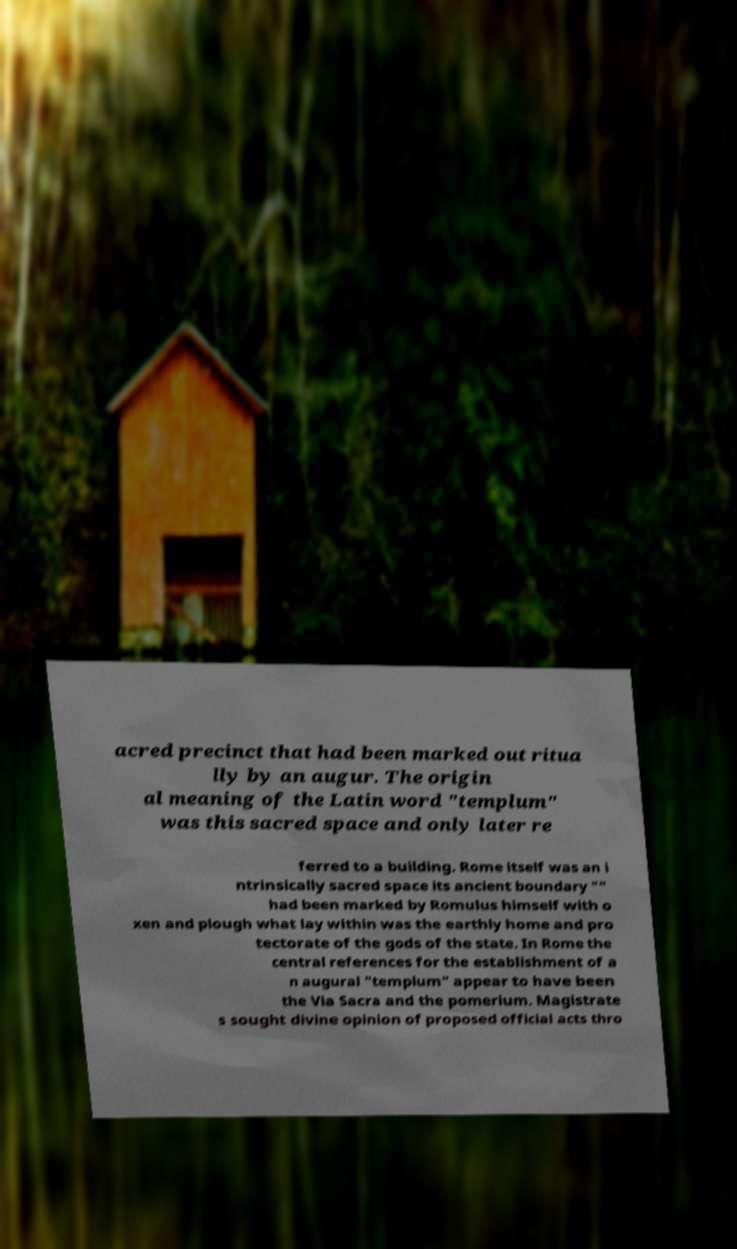Please read and relay the text visible in this image. What does it say? acred precinct that had been marked out ritua lly by an augur. The origin al meaning of the Latin word "templum" was this sacred space and only later re ferred to a building. Rome itself was an i ntrinsically sacred space its ancient boundary "" had been marked by Romulus himself with o xen and plough what lay within was the earthly home and pro tectorate of the gods of the state. In Rome the central references for the establishment of a n augural "templum" appear to have been the Via Sacra and the pomerium. Magistrate s sought divine opinion of proposed official acts thro 